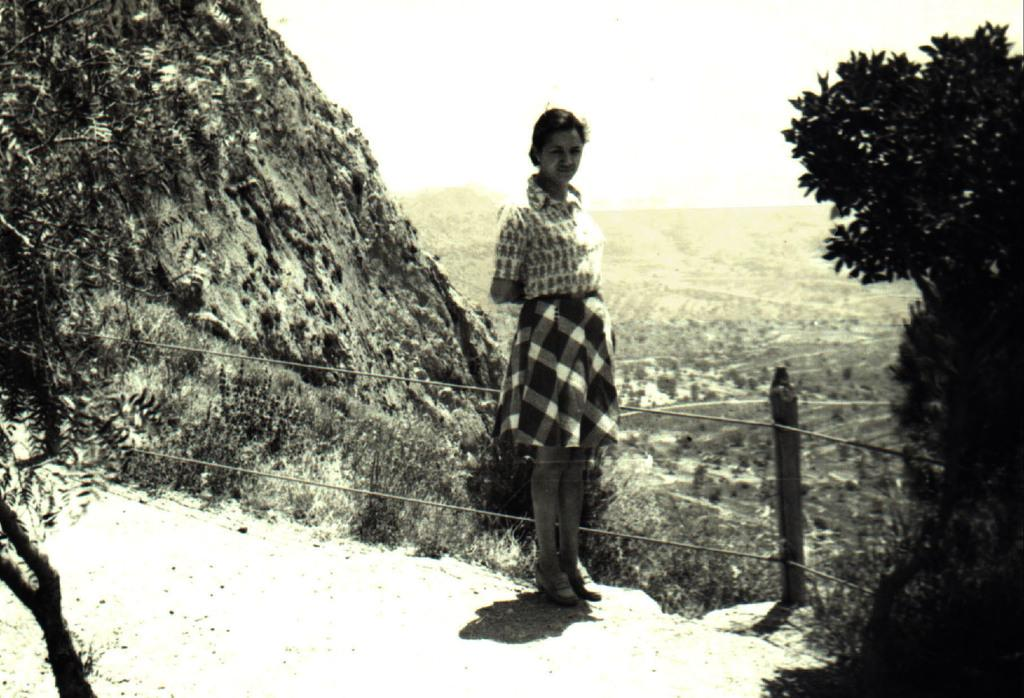What is the main subject of the image? There is a lady standing in the image. How is the lady positioned in the image? The lady is standing. What can be seen near the lady in the image? There is a pole with ropes in the image. What type of natural elements are present in the image? There are trees and a hill in the image. How would you describe the background of the image? The background of the image is blurred. How many sheep are visible in the image? There are no sheep present in the image. What type of glove is the lady wearing in the image? The image does not show the lady wearing a glove. 